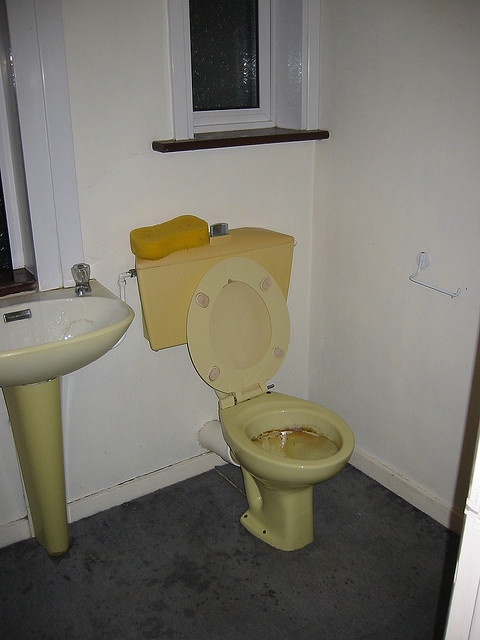Describe the objects in this image and their specific colors. I can see toilet in black and olive tones and sink in black, darkgray, darkgreen, and gray tones in this image. 